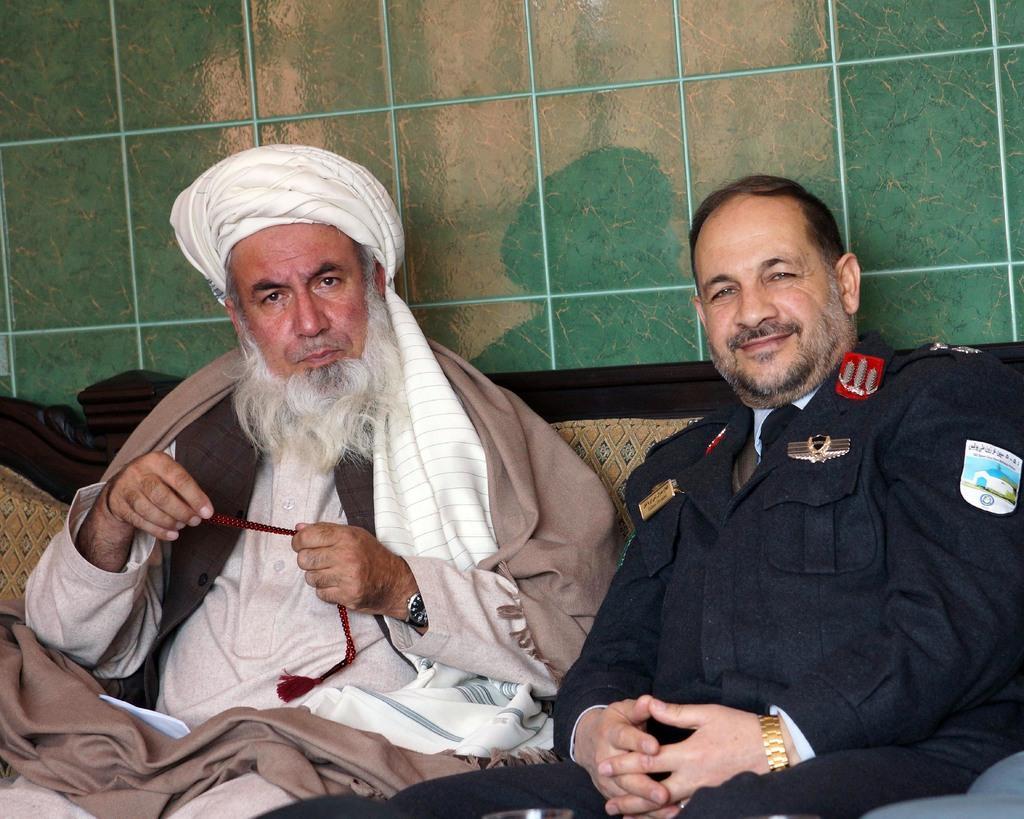Describe this image in one or two sentences. In the image two persons are sitting on a couch and smiling. Behind them there is a wall. 